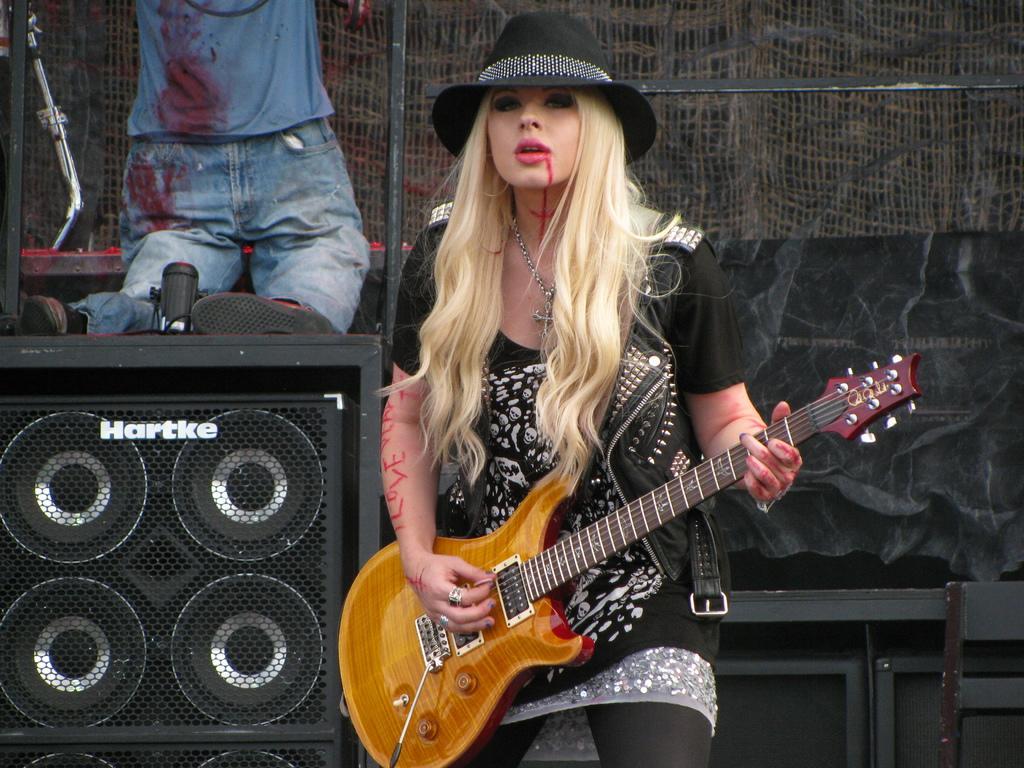Could you give a brief overview of what you see in this image? In this image there is a girl who is playing the guitar with a hat on her head. There is a chain on her neck. At the background there are speakers,net and a man. 